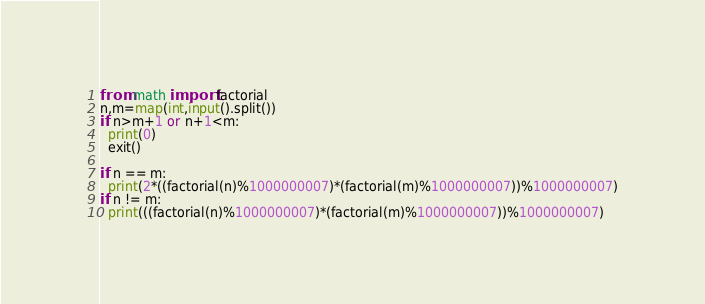<code> <loc_0><loc_0><loc_500><loc_500><_Python_>from math import factorial
n,m=map(int,input().split())
if n>m+1 or n+1<m:
  print(0)
  exit()

if n == m:
  print(2*((factorial(n)%1000000007)*(factorial(m)%1000000007))%1000000007)
if n != m:
  print(((factorial(n)%1000000007)*(factorial(m)%1000000007))%1000000007)</code> 